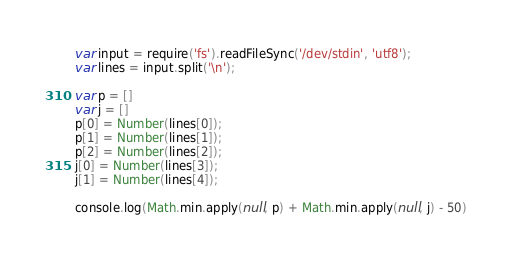Convert code to text. <code><loc_0><loc_0><loc_500><loc_500><_JavaScript_>var input = require('fs').readFileSync('/dev/stdin', 'utf8');
var lines = input.split('\n');

var p = []
var j = []
p[0] = Number(lines[0]);
p[1] = Number(lines[1]);
p[2] = Number(lines[2]);
j[0] = Number(lines[3]);
j[1] = Number(lines[4]);

console.log(Math.min.apply(null, p) + Math.min.apply(null, j) - 50)</code> 